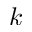Convert formula to latex. <formula><loc_0><loc_0><loc_500><loc_500>k</formula> 